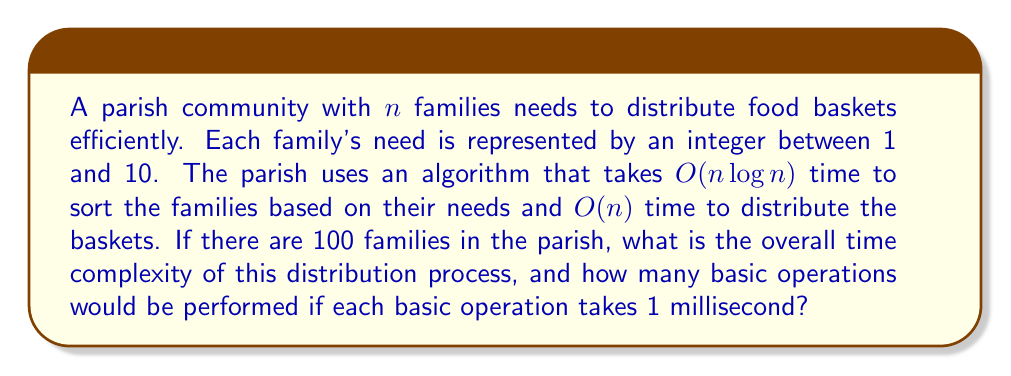Show me your answer to this math problem. To solve this problem, we need to follow these steps:

1. Determine the overall time complexity:
   - Sorting: $O(n \log n)$
   - Distribution: $O(n)$
   The overall time complexity is the sum of these two: $O(n \log n + n)$
   Since $n \log n$ grows faster than $n$, we can simplify this to $O(n \log n)$

2. Calculate the number of operations for $n = 100$:
   - The exact number of operations in $O(n \log n)$ algorithms can vary, but a common form is $c \cdot n \log n$ where $c$ is a constant.
   - For this example, let's assume $c = 2$
   - Number of operations $= 2 \cdot 100 \log 100$
   - $\log 100 \approx 6.64$ (using base 2 logarithm)
   - Number of operations $\approx 2 \cdot 100 \cdot 6.64 = 1328$

3. Convert to milliseconds:
   - If each operation takes 1 ms, then the total time is approximately 1328 ms or 1.328 seconds

This process demonstrates how computational complexity can be applied to a real-world scenario of resource distribution in a parish community, showing how the time taken scales with the number of families involved.
Answer: The overall time complexity is $O(n \log n)$, and for 100 families, it would perform approximately 1328 basic operations, taking about 1.328 seconds if each operation takes 1 millisecond. 